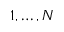Convert formula to latex. <formula><loc_0><loc_0><loc_500><loc_500>1 , \hdots , N</formula> 